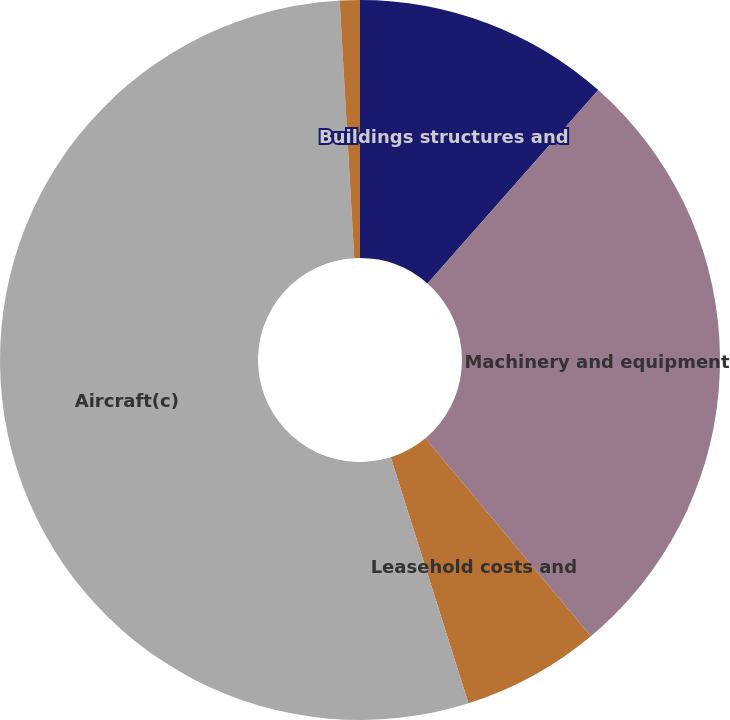<chart> <loc_0><loc_0><loc_500><loc_500><pie_chart><fcel>Buildings structures and<fcel>Machinery and equipment<fcel>Leasehold costs and<fcel>Aircraft(c)<fcel>All other<nl><fcel>11.51%<fcel>27.41%<fcel>6.21%<fcel>53.97%<fcel>0.9%<nl></chart> 